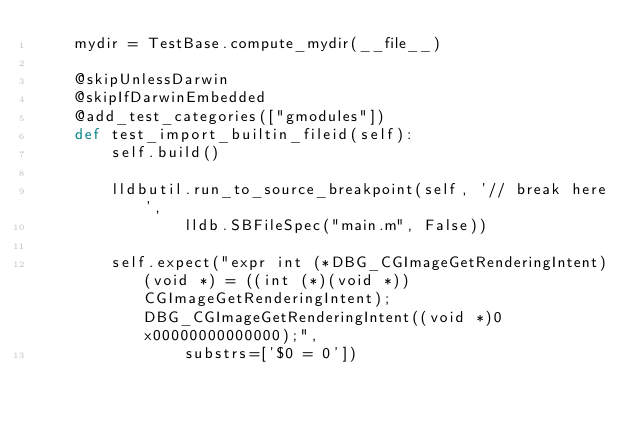Convert code to text. <code><loc_0><loc_0><loc_500><loc_500><_Python_>    mydir = TestBase.compute_mydir(__file__)

    @skipUnlessDarwin
    @skipIfDarwinEmbedded
    @add_test_categories(["gmodules"])
    def test_import_builtin_fileid(self):
        self.build()

        lldbutil.run_to_source_breakpoint(self, '// break here',
                lldb.SBFileSpec("main.m", False))

        self.expect("expr int (*DBG_CGImageGetRenderingIntent)(void *) = ((int (*)(void *))CGImageGetRenderingIntent); DBG_CGImageGetRenderingIntent((void *)0x00000000000000);", 
                substrs=['$0 = 0'])
</code> 